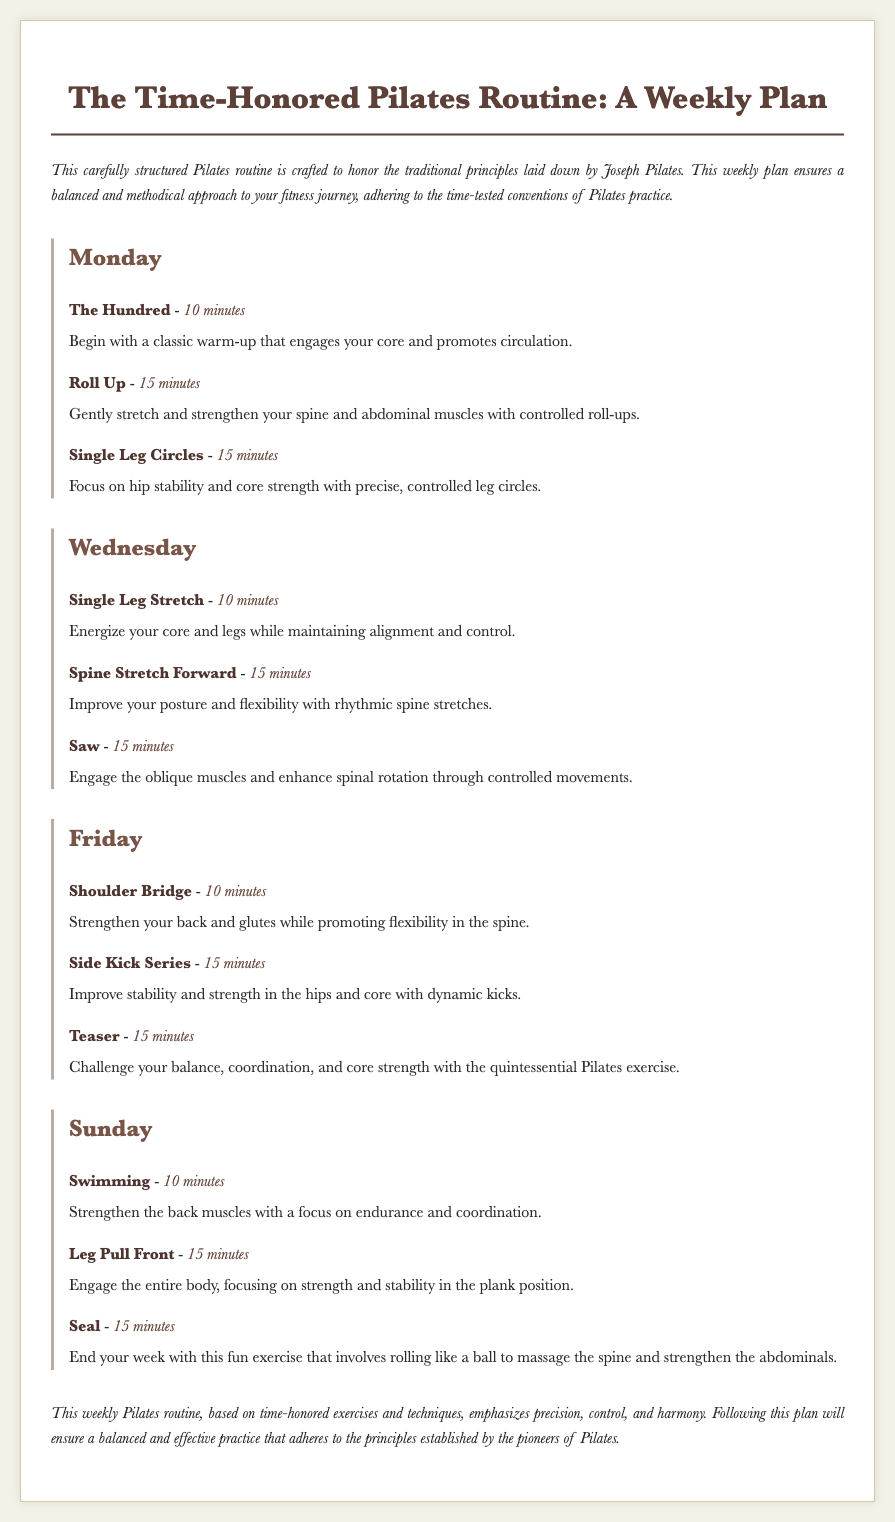What is the title of the document? The title is clearly provided at the top of the document in a prominent heading format.
Answer: The Time-Honored Pilates Routine: A Weekly Plan How many exercises are listed for each day? Each day features three exercises according to the structure outlined in the document.
Answer: Three What is the duration of "The Hundred"? The duration is explicitly stated alongside the exercise description in the document.
Answer: 10 minutes What exercise is performed on Friday that focuses on strengthening the back? This information can be found by reviewing the listed exercises for Friday's session.
Answer: Shoulder Bridge On which day is "Swimming" included in the routine? The day is specified in the section detailing the Sunday exercises.
Answer: Sunday What type of routine is described in the document? The document describes a routine that adheres to traditional fitness principles.
Answer: Pilates What is emphasized as a key quality of the weekly Pilates routine? This detail is mentioned in the conclusion summarizing the goals of the plan.
Answer: Precision How does the plan conclude regarding the practice? The conclusion provides insight into the intended outcome of following the routine as outlined.
Answer: Balanced and effective practice 